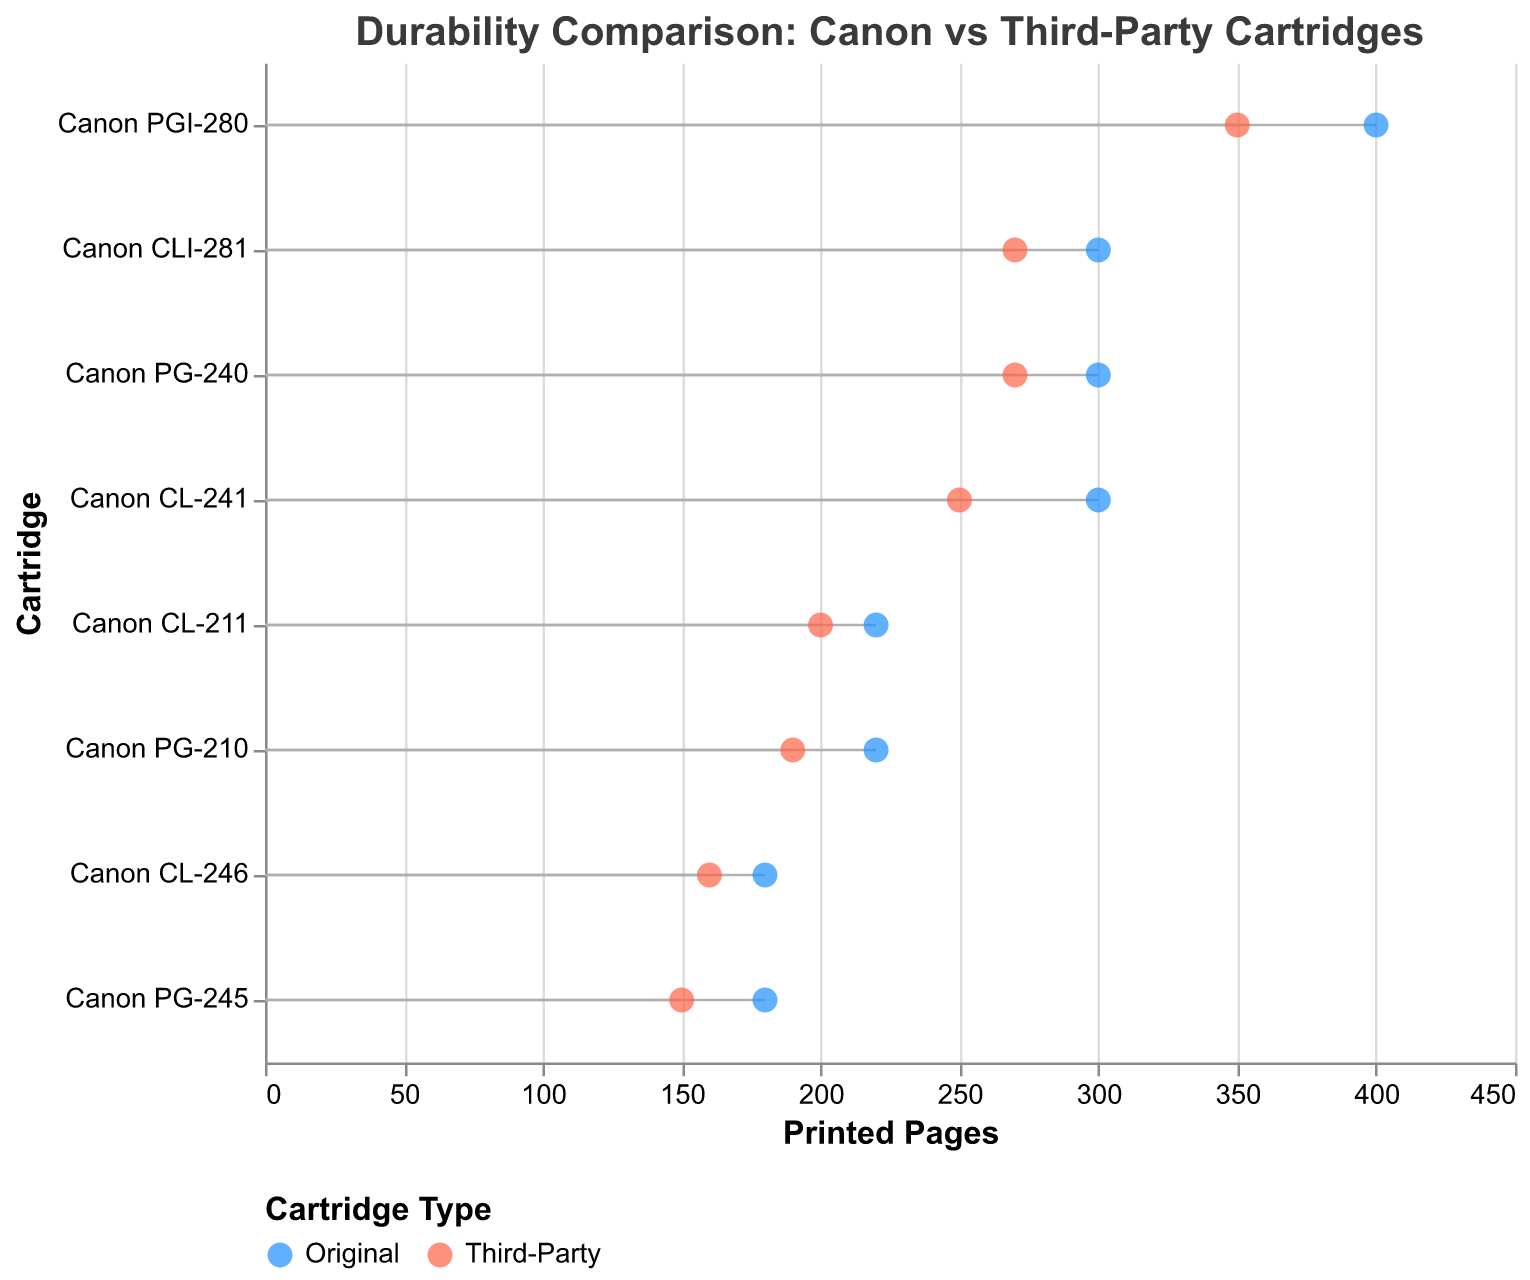What is the title of the figure? The title can be found at the top of the figure. It reads "Durability Comparison: Canon vs Third-Party Cartridges."
Answer: Durability Comparison: Canon vs Third-Party Cartridges What do the blue and red dots represent in the figure? The colors of the points are explained in the legend at the bottom of the figure. Blue dots represent original Canon cartridges, and red dots represent third-party cartridges.
Answer: Blue represents original Canon Cartridges, Red represents third-party cartridges Which cartridge has the maximum number of printed pages for original Canon cartridges? By looking at the blue dots, the highest point on the x-axis is for the Canon PGI-280 cartridge, which has 400 printed pages.
Answer: Canon PGI-280 What is the difference in the number of printed pages between original Canon and third-party cartridges for the Canon PG-240? Locate the points for the Canon PG-240 cartridge; the original Canon prints 300 pages and the third-party prints 270 pages. The difference is 300 - 270 = 30.
Answer: 30 Which cartridge shows the smallest difference in printed pages between original Canon and third-party cartridges? Compare the differences for each cartridge. Canon CL-246 has the smallest difference, with original Canon at 180 and third-party at 160, giving a difference of 20 pages.
Answer: Canon CL-246 How many cartridges have more than 300 printed pages for original Canon cartridges? Look at the blue dots to count cartridges with more than 300 printed pages. These are Canon PGI-280 (400) and Canon PG-240, CL-241, and CLI-281 (each 300).
Answer: 3 Which original Canon cartridge has the same number of printed pages as its third-party counterpart? None of the original Canon cartridges have the same number of printed pages as their third-party counterparts. Each pair has different values.
Answer: None For which cartridge is the difference between original Canon and third-party cartridges the largest? Check the differences for each cartridge. The largest difference is for the Canon PGI-280, where the difference is 400 - 350 = 50 pages.
Answer: Canon PGI-280 What is the range of printed pages for third-party cartridges? The range is found by subtracting the smallest value of printed pages for third-party cartridges from the largest value. The smallest is 150 (Canon PG-245), and the largest is 350 (Canon PGI-280). The range is 350 - 150 = 200.
Answer: 200 